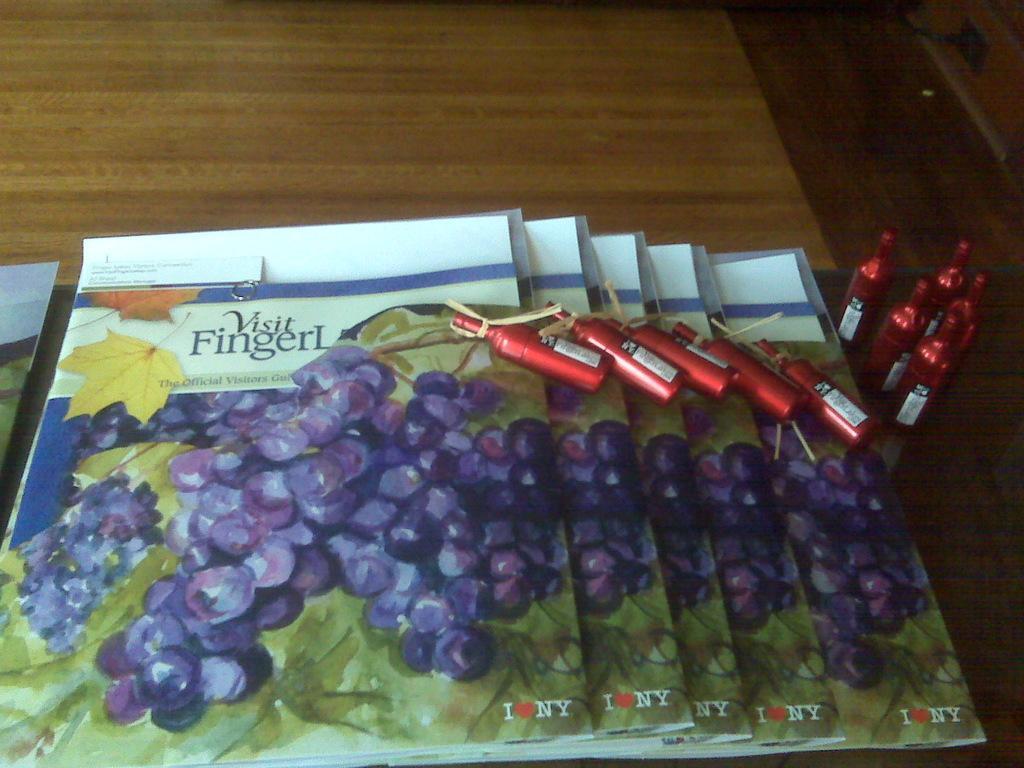In one or two sentences, can you explain what this image depicts? In this image, I think these are the books and the tiny bottles, which are placed on the table. These bottles are red in color. 